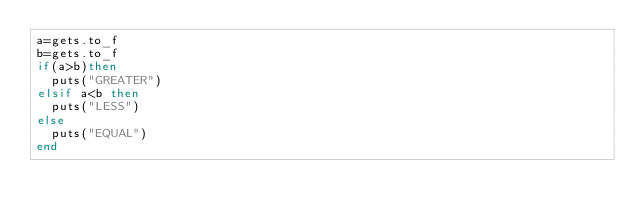Convert code to text. <code><loc_0><loc_0><loc_500><loc_500><_Ruby_>a=gets.to_f
b=gets.to_f
if(a>b)then
  puts("GREATER")
elsif a<b then
  puts("LESS")
else
  puts("EQUAL")
end
</code> 